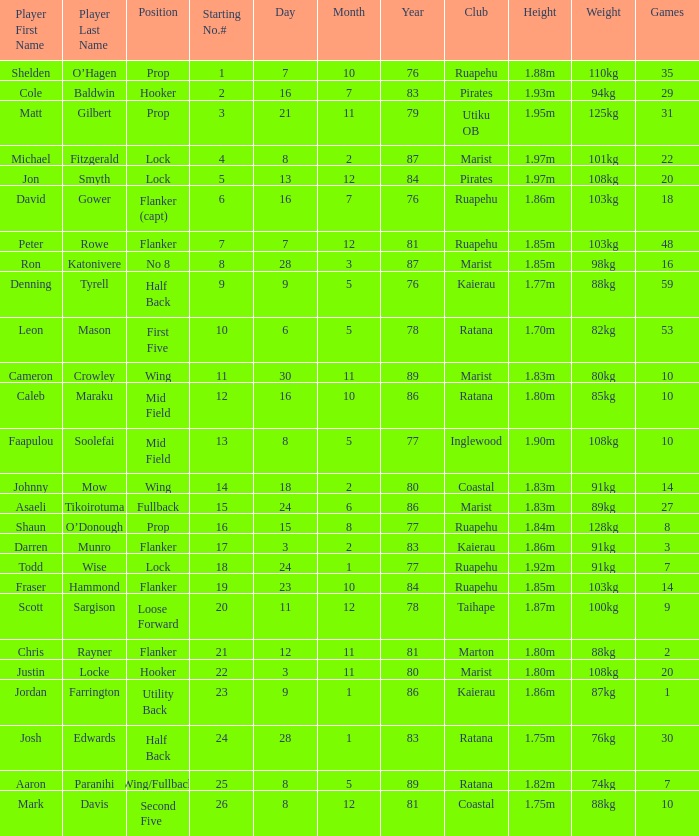Which player weighs 76kg? Josh Edwards. 